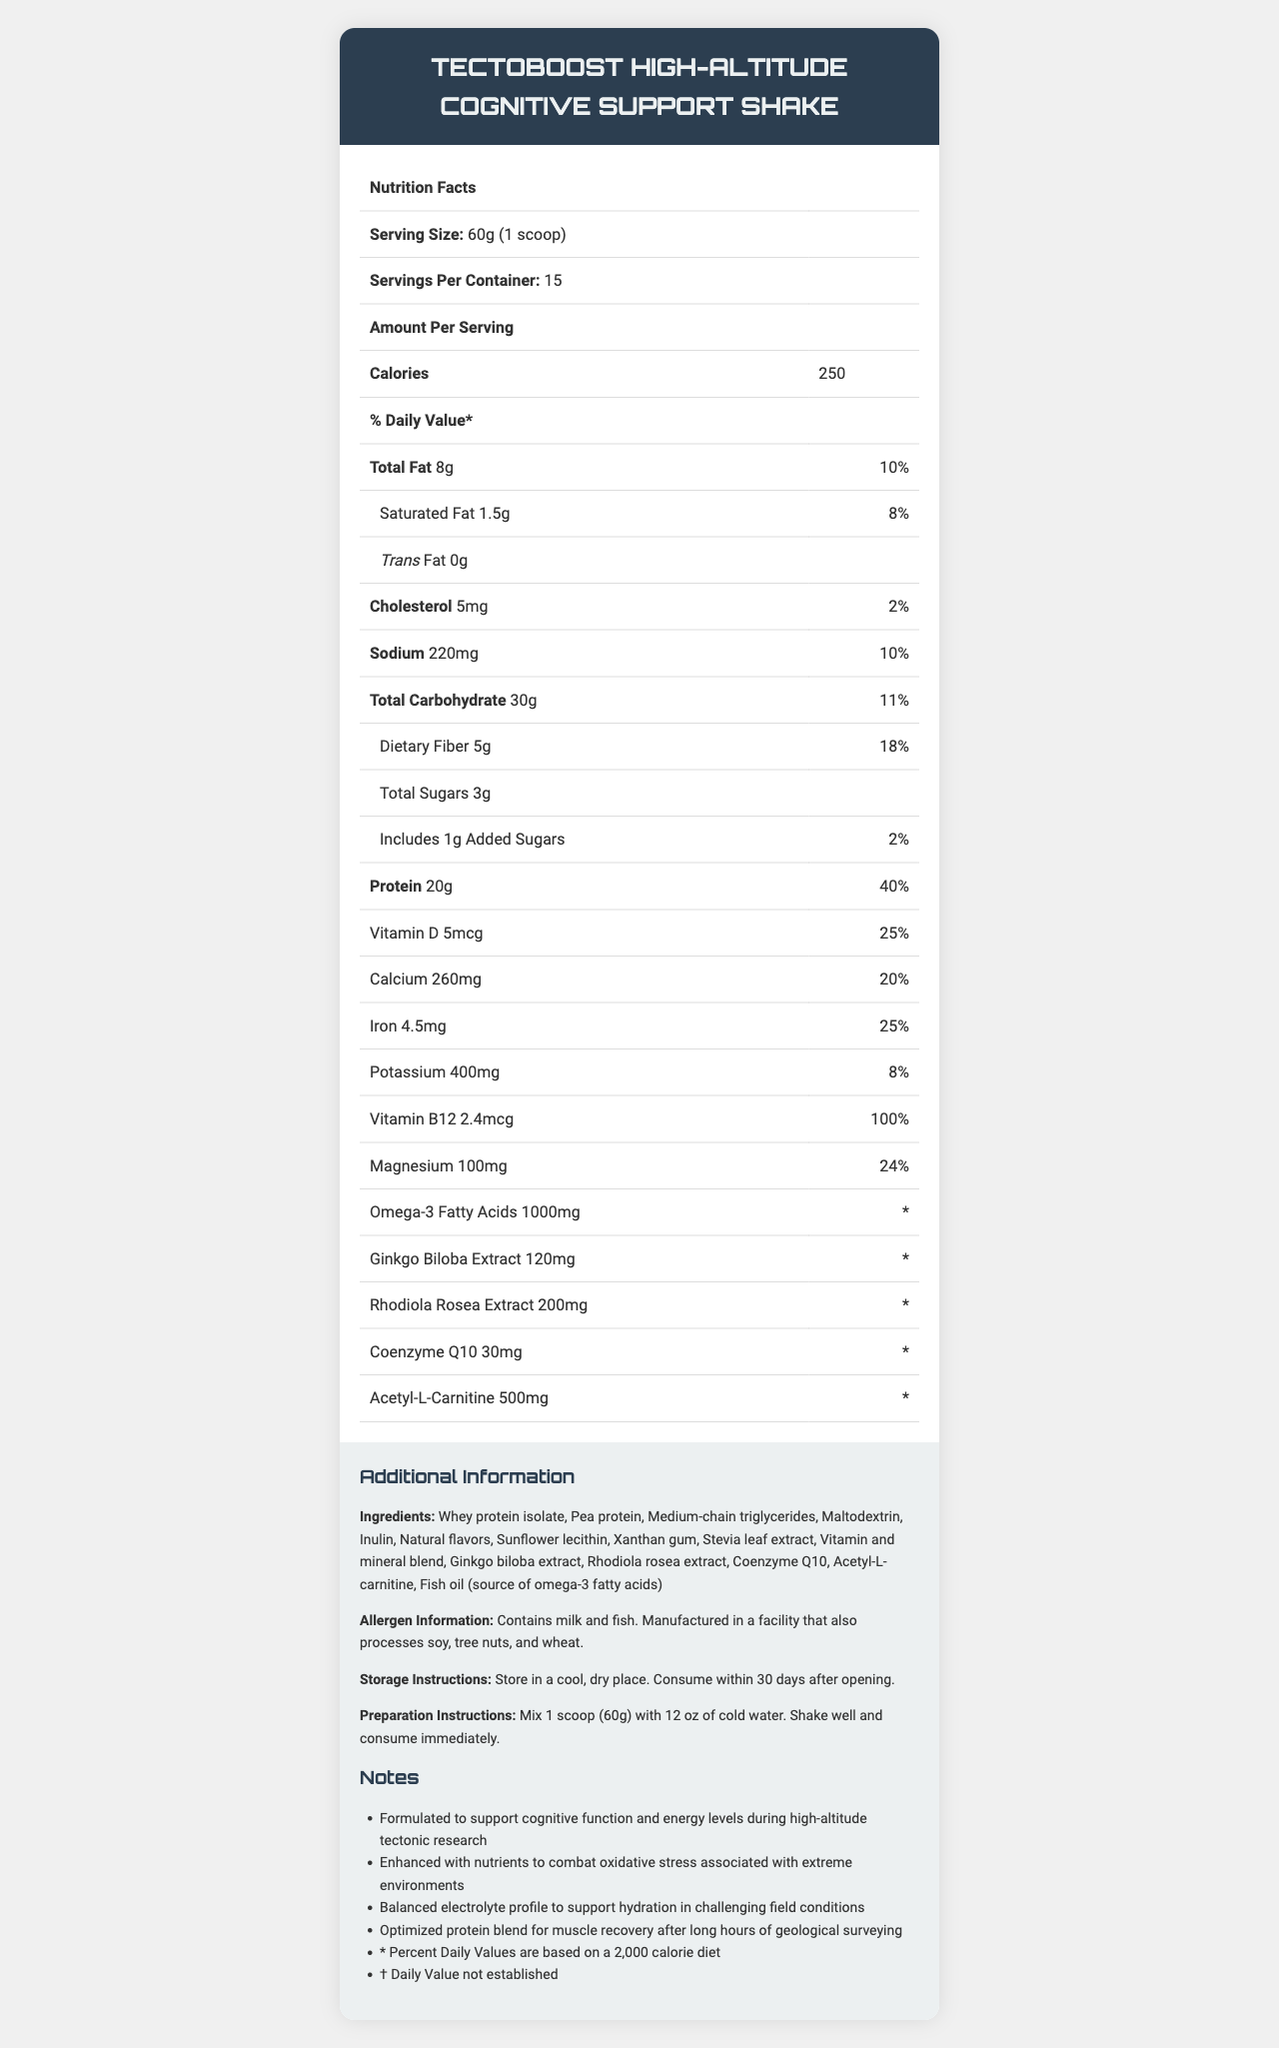who is the product name? The product name is displayed at the top of the document under the "Nutrition Facts" header.
Answer: TectoBoost High-Altitude Cognitive Support Shake how many calories are in one serving? Under the "Amount Per Serving" section, it lists the calories as 250.
Answer: 250 what is the serving size? The serving size information is listed under "Nutrition Facts" at the top of the document.
Answer: 60g (1 scoop) what is the total fat content per serving? The total fat content is listed under "Total Fat" in the "Amount Per Serving" section.
Answer: 8g which ingredient is a source of omega-3 fatty acids? A. Rhodiola Rosea Extract B. Fish Oil C. Acetyl-L-Carnitine The ingredient list includes "Fish oil (source of omega-3 fatty acids)".
Answer: B how many servings are there per container? The "Servings Per Container" is listed under the "Nutrition Facts" at the top.
Answer: 15 is this product suitable for someone with a soy allergy? The allergen information states that it is manufactured in a facility that also processes soy.
Answer: No how much dietary fiber is in each serving? In the "Amount Per Serving" section, dietary fiber is listed as 5g.
Answer: 5g how much protein will you get if you consume 2 servings? A. 20g B. 40g C. 60g Each serving contains 20g of protein. So, 2 servings will have 20g x 2 = 40g of protein.
Answer: B how much Magnesium is in one serving? The "Amount Per Serving" section lists magnesium as 100mg.
Answer: 100mg how much water should you mix with one scoop? A. 10 oz B. 12 oz C. 15 oz The preparation instructions advise mixing 1 scoop (60g) with 12 oz of cold water.
Answer: B does this product contain any added sugars? Under the "Total Sugars" section, it includes 1g of added sugars.
Answer: Yes should this product be stored in a refrigerated environment? The storage instructions state to store in a cool, dry place.
Answer: No does this product help with muscle recovery? One of the additional notes states that the product has an optimized protein blend for muscle recovery.
Answer: Yes 